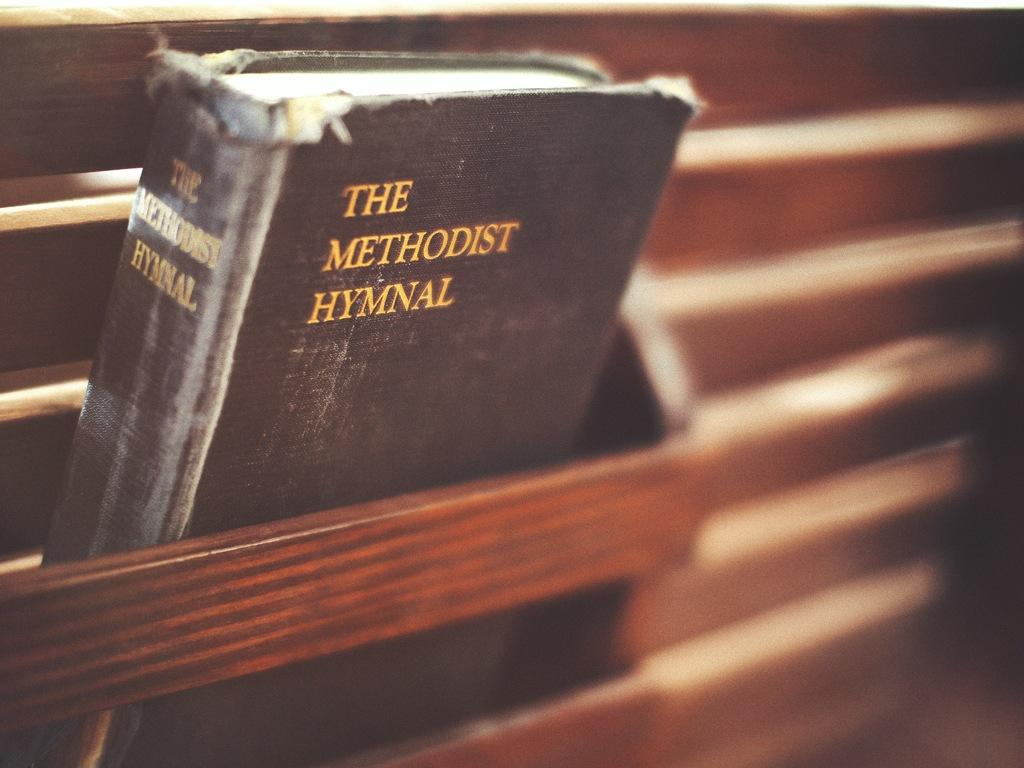<image>
Provide a brief description of the given image. A book sits in a wooden ledge called The Methodist Hymnal. 